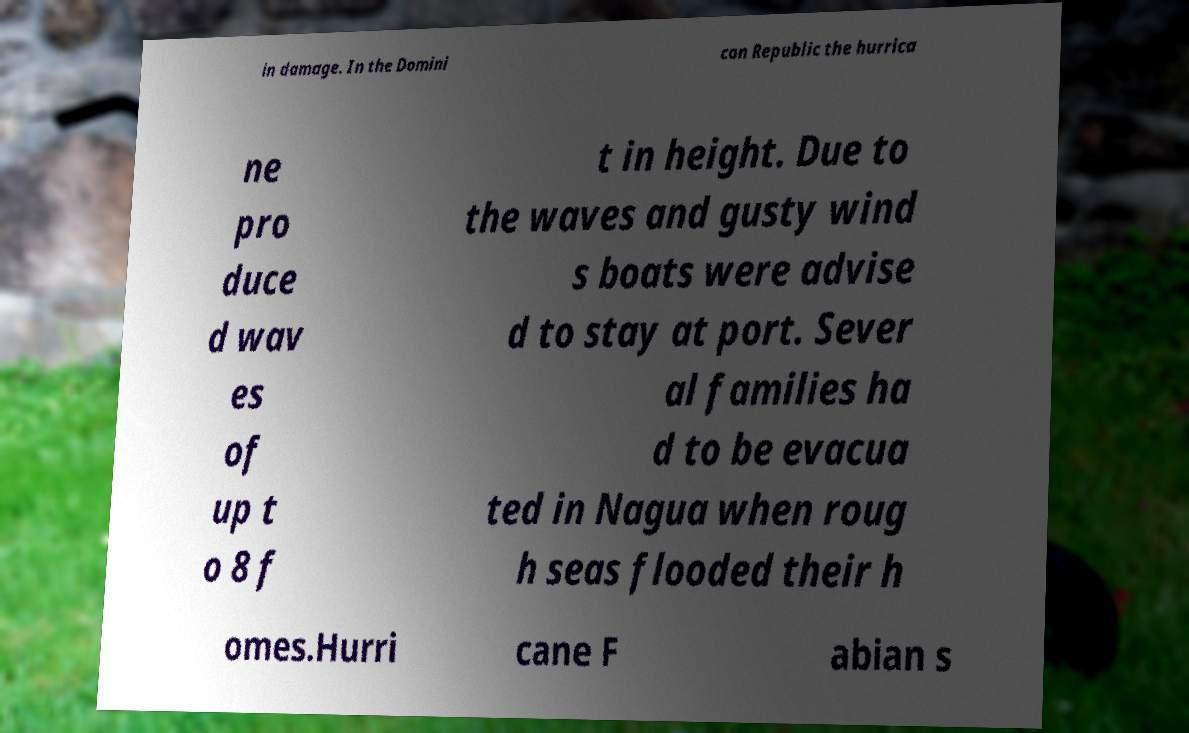I need the written content from this picture converted into text. Can you do that? in damage. In the Domini can Republic the hurrica ne pro duce d wav es of up t o 8 f t in height. Due to the waves and gusty wind s boats were advise d to stay at port. Sever al families ha d to be evacua ted in Nagua when roug h seas flooded their h omes.Hurri cane F abian s 